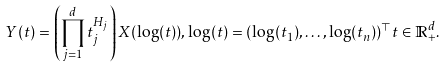<formula> <loc_0><loc_0><loc_500><loc_500>Y ( t ) = \left ( \prod _ { j = 1 } ^ { d } t _ { j } ^ { H _ { j } } \right ) X ( \log ( t ) ) , \log ( t ) = ( \log ( t _ { 1 } ) , \dots , \log ( t _ { n } ) ) ^ { \top } t \in \mathbb { R } ^ { d } _ { + } .</formula> 